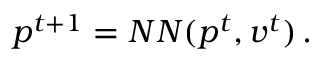Convert formula to latex. <formula><loc_0><loc_0><loc_500><loc_500>p ^ { t + 1 } = N N ( p ^ { t } , v ^ { t } ) \, .</formula> 